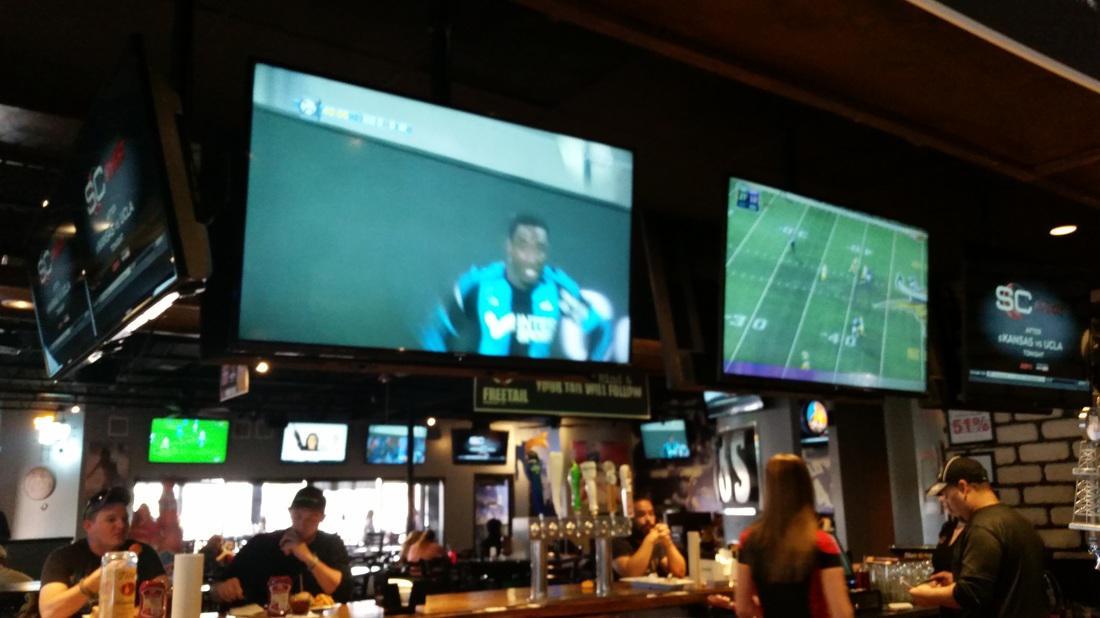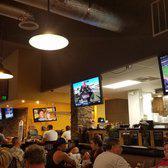The first image is the image on the left, the second image is the image on the right. Evaluate the accuracy of this statement regarding the images: "A bar image includes no more than two customers in the foreground, sitting with back to the camera watching TV screens.". Is it true? Answer yes or no. No. 